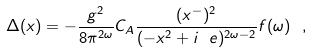<formula> <loc_0><loc_0><loc_500><loc_500>\Delta ( x ) = - \frac { g ^ { 2 } } { 8 \pi ^ { 2 \omega } } C _ { A } \frac { ( x ^ { - } ) ^ { 2 } } { ( - x ^ { 2 } + i \ e ) ^ { 2 \omega - 2 } } f ( \omega ) \ ,</formula> 